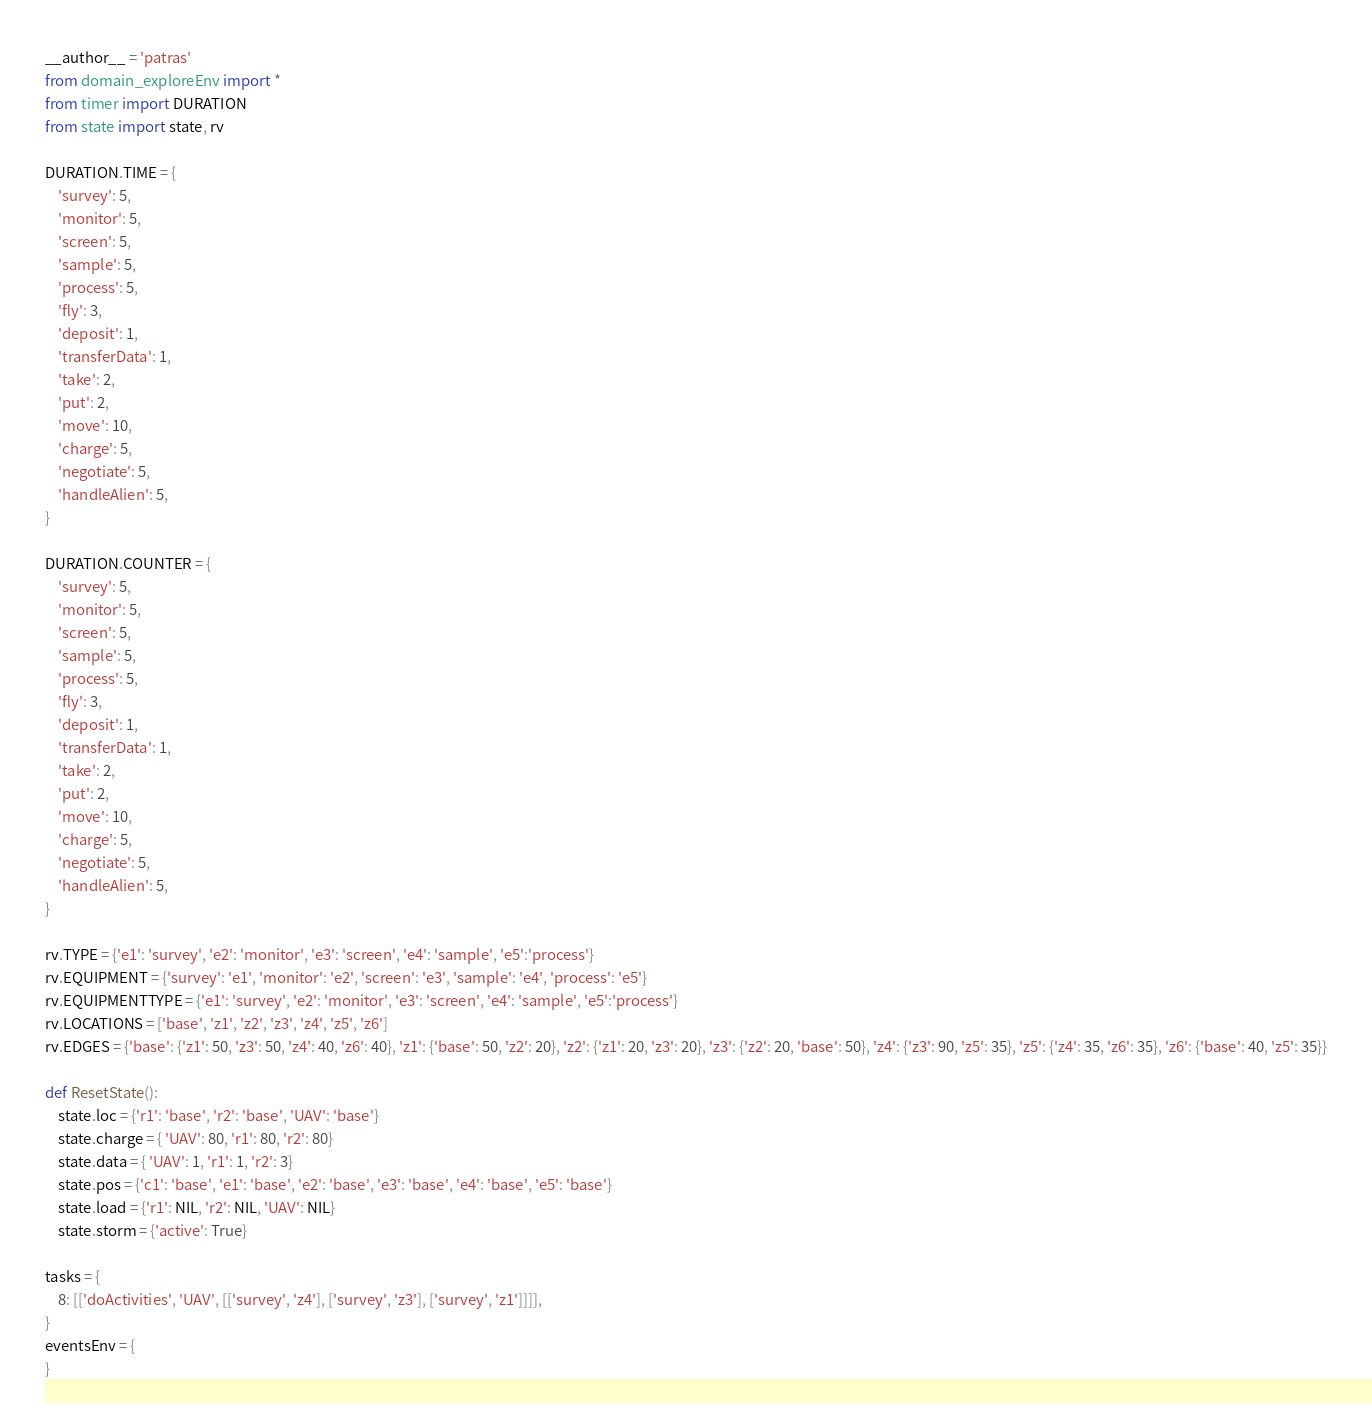Convert code to text. <code><loc_0><loc_0><loc_500><loc_500><_Python_>__author__ = 'patras'
from domain_exploreEnv import *
from timer import DURATION
from state import state, rv

DURATION.TIME = {
    'survey': 5,
    'monitor': 5,
    'screen': 5,
    'sample': 5,
    'process': 5,
    'fly': 3,
    'deposit': 1,
    'transferData': 1,
    'take': 2,
    'put': 2,
    'move': 10,
    'charge': 5,
    'negotiate': 5,
    'handleAlien': 5,
}

DURATION.COUNTER = {
    'survey': 5,
    'monitor': 5,
    'screen': 5,
    'sample': 5,
    'process': 5,
    'fly': 3,
    'deposit': 1,
    'transferData': 1,
    'take': 2,
    'put': 2,
    'move': 10,
    'charge': 5,
    'negotiate': 5,
    'handleAlien': 5,
}

rv.TYPE = {'e1': 'survey', 'e2': 'monitor', 'e3': 'screen', 'e4': 'sample', 'e5':'process'}
rv.EQUIPMENT = {'survey': 'e1', 'monitor': 'e2', 'screen': 'e3', 'sample': 'e4', 'process': 'e5'}
rv.EQUIPMENTTYPE = {'e1': 'survey', 'e2': 'monitor', 'e3': 'screen', 'e4': 'sample', 'e5':'process'}
rv.LOCATIONS = ['base', 'z1', 'z2', 'z3', 'z4', 'z5', 'z6']
rv.EDGES = {'base': {'z1': 50, 'z3': 50, 'z4': 40, 'z6': 40}, 'z1': {'base': 50, 'z2': 20}, 'z2': {'z1': 20, 'z3': 20}, 'z3': {'z2': 20, 'base': 50}, 'z4': {'z3': 90, 'z5': 35}, 'z5': {'z4': 35, 'z6': 35}, 'z6': {'base': 40, 'z5': 35}}

def ResetState():
    state.loc = {'r1': 'base', 'r2': 'base', 'UAV': 'base'}
    state.charge = { 'UAV': 80, 'r1': 80, 'r2': 80}
    state.data = { 'UAV': 1, 'r1': 1, 'r2': 3}
    state.pos = {'c1': 'base', 'e1': 'base', 'e2': 'base', 'e3': 'base', 'e4': 'base', 'e5': 'base'}
    state.load = {'r1': NIL, 'r2': NIL, 'UAV': NIL}
    state.storm = {'active': True}

tasks = {
    8: [['doActivities', 'UAV', [['survey', 'z4'], ['survey', 'z3'], ['survey', 'z1']]]],
}
eventsEnv = {
}</code> 